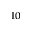Convert formula to latex. <formula><loc_0><loc_0><loc_500><loc_500>^ { 1 0 }</formula> 